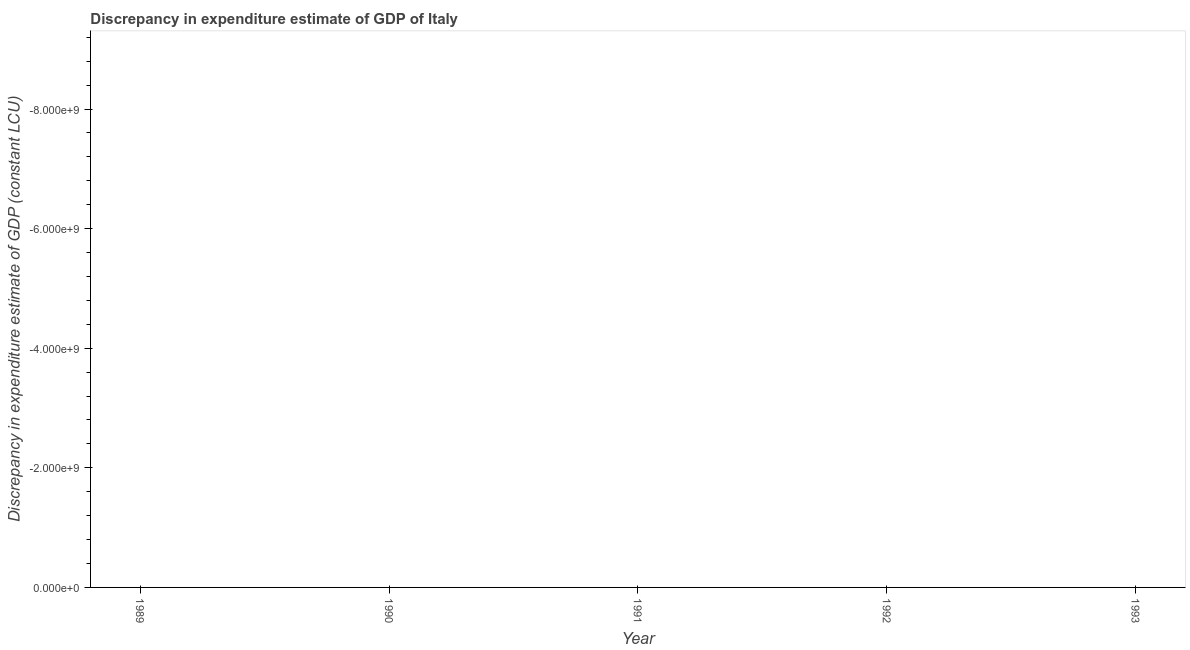What is the discrepancy in expenditure estimate of gdp in 1990?
Make the answer very short. 0. Across all years, what is the minimum discrepancy in expenditure estimate of gdp?
Provide a succinct answer. 0. What is the sum of the discrepancy in expenditure estimate of gdp?
Your response must be concise. 0. What is the average discrepancy in expenditure estimate of gdp per year?
Provide a succinct answer. 0. Does the discrepancy in expenditure estimate of gdp monotonically increase over the years?
Provide a short and direct response. No. How many years are there in the graph?
Your response must be concise. 5. Does the graph contain any zero values?
Offer a very short reply. Yes. What is the title of the graph?
Provide a succinct answer. Discrepancy in expenditure estimate of GDP of Italy. What is the label or title of the X-axis?
Your response must be concise. Year. What is the label or title of the Y-axis?
Offer a terse response. Discrepancy in expenditure estimate of GDP (constant LCU). What is the Discrepancy in expenditure estimate of GDP (constant LCU) in 1989?
Your answer should be compact. 0. What is the Discrepancy in expenditure estimate of GDP (constant LCU) in 1990?
Provide a succinct answer. 0. What is the Discrepancy in expenditure estimate of GDP (constant LCU) in 1993?
Your answer should be very brief. 0. 